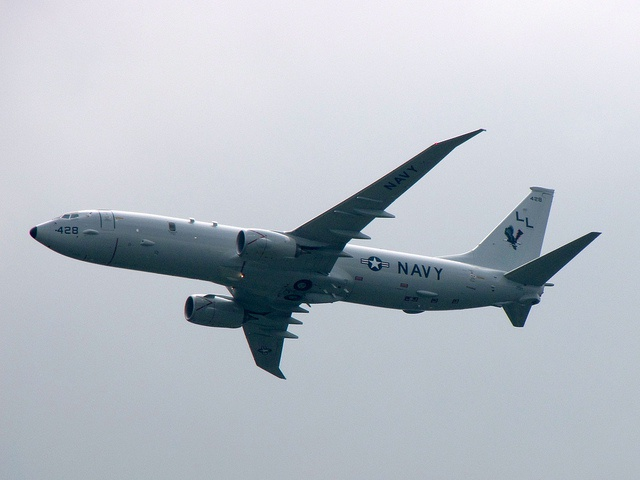Describe the objects in this image and their specific colors. I can see a airplane in lightgray, darkblue, gray, and blue tones in this image. 